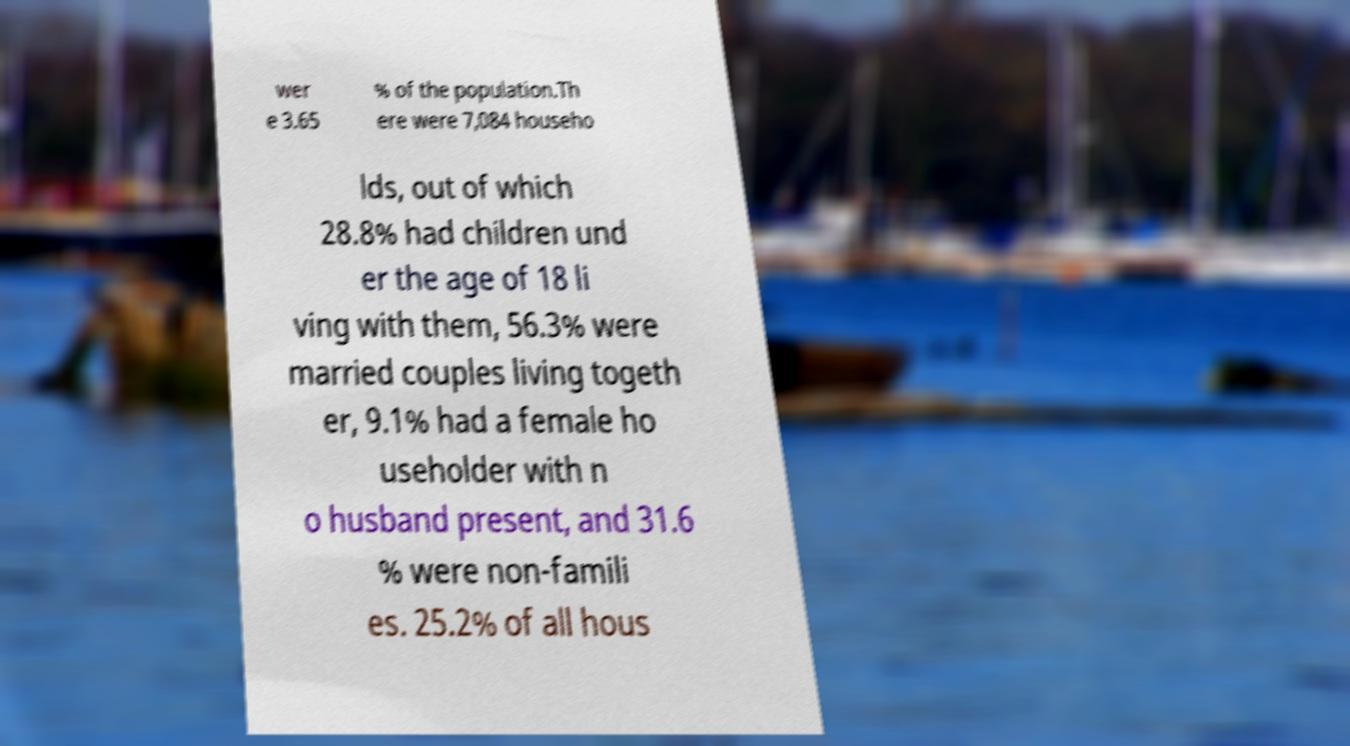Please identify and transcribe the text found in this image. wer e 3.65 % of the population.Th ere were 7,084 househo lds, out of which 28.8% had children und er the age of 18 li ving with them, 56.3% were married couples living togeth er, 9.1% had a female ho useholder with n o husband present, and 31.6 % were non-famili es. 25.2% of all hous 